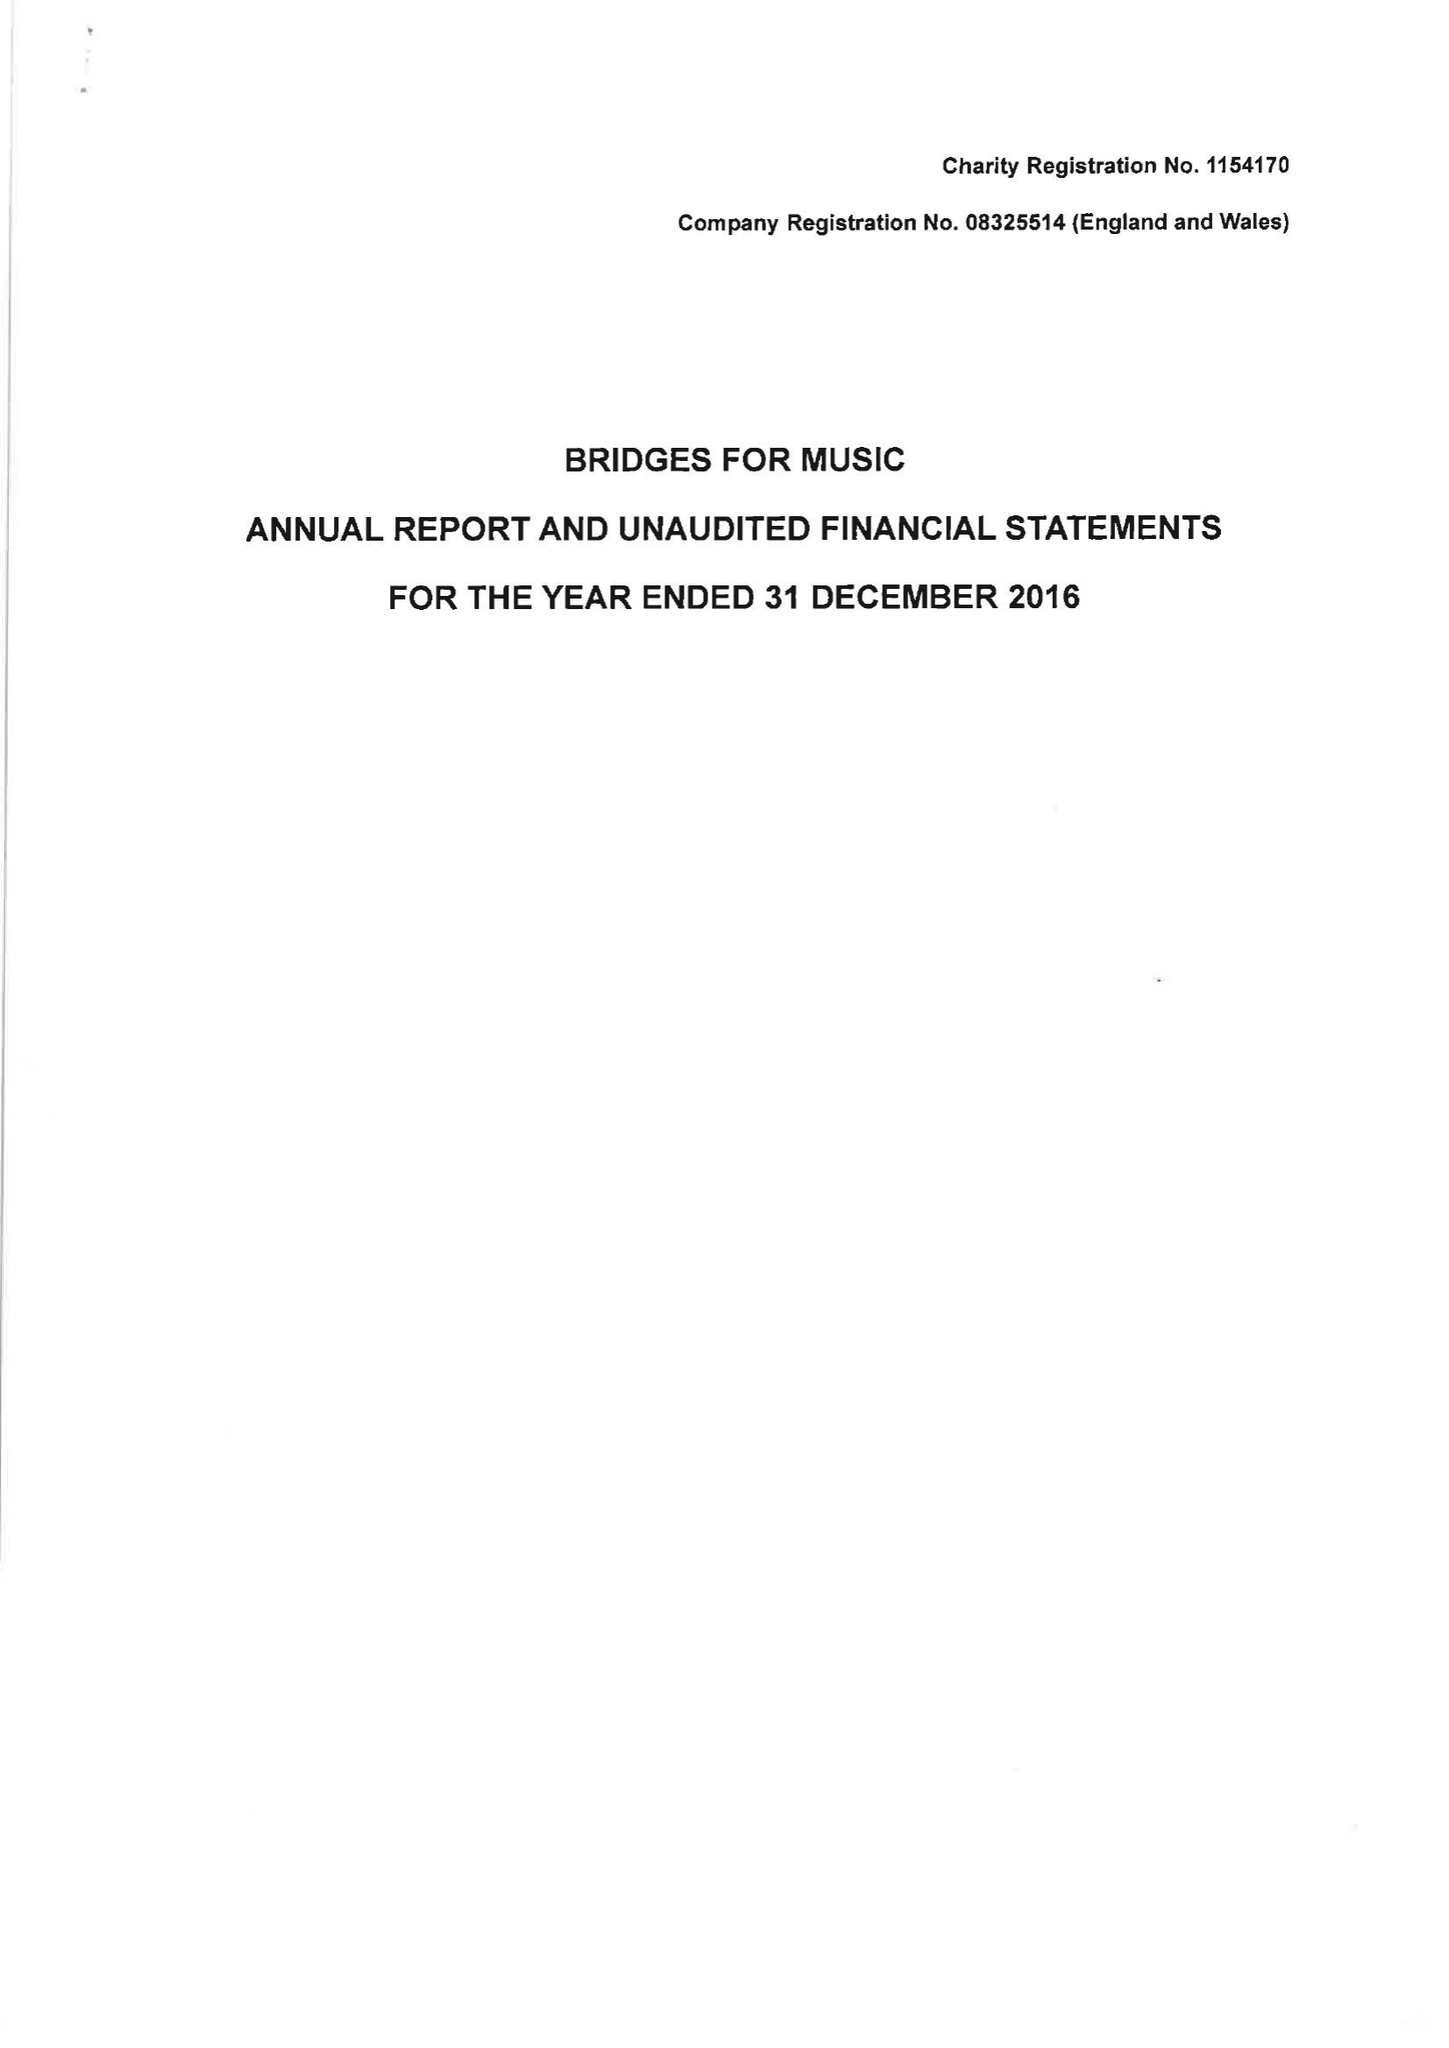What is the value for the spending_annually_in_british_pounds?
Answer the question using a single word or phrase. 118486.00 